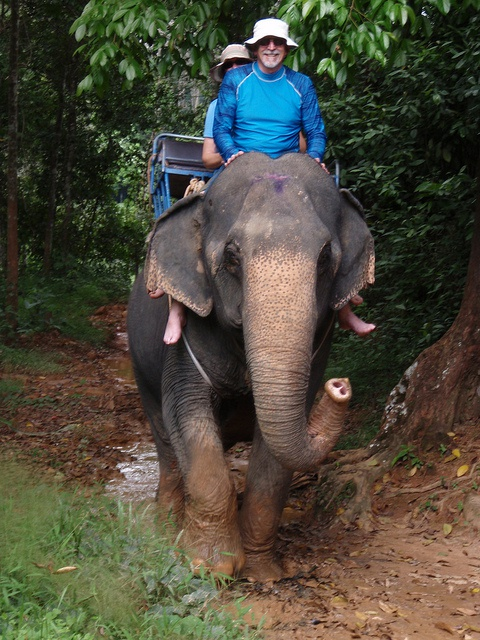Describe the objects in this image and their specific colors. I can see elephant in black, gray, and maroon tones, people in black, lightblue, blue, navy, and white tones, and people in black, blue, lightpink, and lightgray tones in this image. 